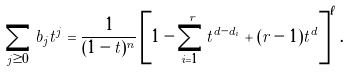Convert formula to latex. <formula><loc_0><loc_0><loc_500><loc_500>\sum _ { j \geq 0 } b _ { j } t ^ { j } = \frac { 1 } { ( 1 - t ) ^ { n } } \left [ 1 - \sum ^ { r } _ { i = 1 } t ^ { d - d _ { i } } + ( r - 1 ) t ^ { d } \right ] ^ { \ell } .</formula> 